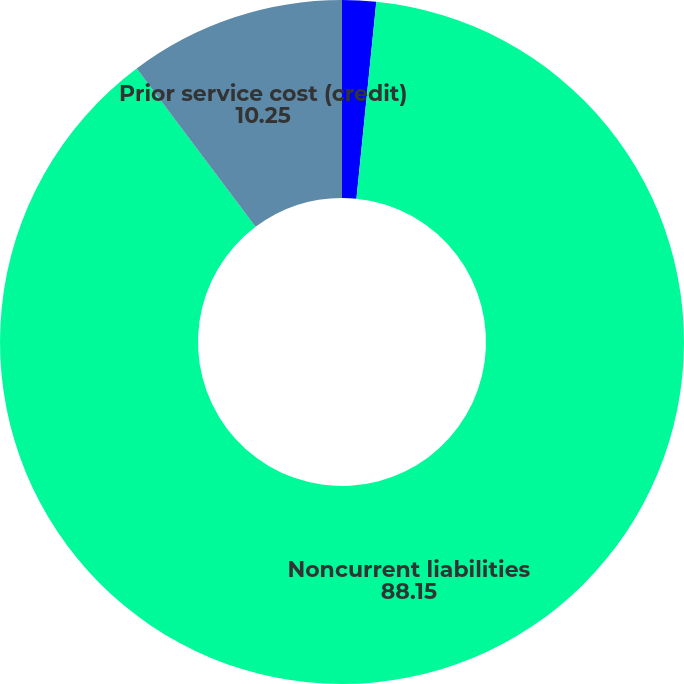Convert chart to OTSL. <chart><loc_0><loc_0><loc_500><loc_500><pie_chart><fcel>Current liabilities<fcel>Noncurrent liabilities<fcel>Prior service cost (credit)<nl><fcel>1.6%<fcel>88.15%<fcel>10.25%<nl></chart> 